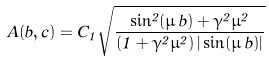Convert formula to latex. <formula><loc_0><loc_0><loc_500><loc_500>A ( b , c ) = C _ { 1 } \sqrt { \frac { \sin ^ { 2 } ( \mu \, b ) + \gamma ^ { 2 } \mu ^ { 2 } } { \left ( 1 + \gamma ^ { 2 } \mu ^ { 2 } \right ) | \sin ( \mu \, b ) | } }</formula> 